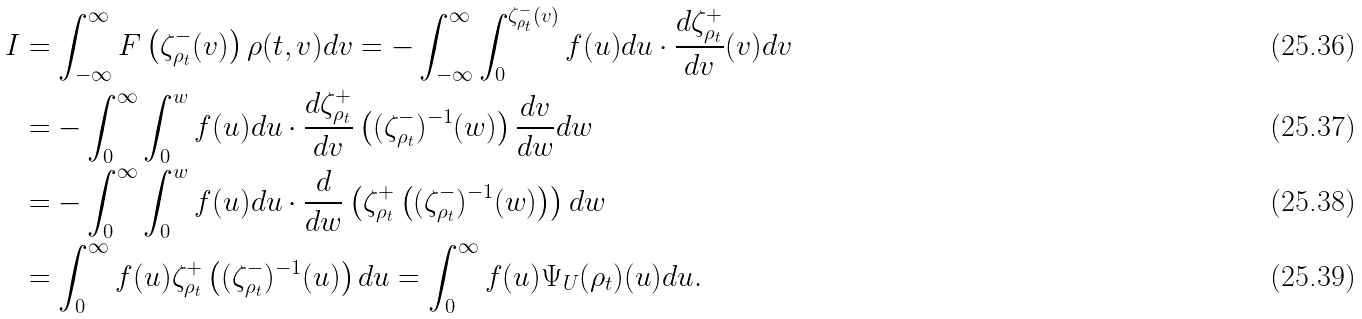Convert formula to latex. <formula><loc_0><loc_0><loc_500><loc_500>I & = \int _ { - \infty } ^ { \infty } F \left ( \zeta ^ { - } _ { \rho _ { t } } ( v ) \right ) \rho ( t , v ) d v = - \int _ { - \infty } ^ { \infty } \int _ { 0 } ^ { \zeta ^ { - } _ { \rho _ { t } } ( v ) } f ( u ) d u \cdot \frac { d \zeta ^ { + } _ { \rho _ { t } } } { d v } ( v ) d v \\ & = - \int _ { 0 } ^ { \infty } \int _ { 0 } ^ { w } f ( u ) d u \cdot \frac { d \zeta ^ { + } _ { \rho _ { t } } } { d v } \left ( ( \zeta ^ { - } _ { \rho _ { t } } ) ^ { - 1 } ( w ) \right ) \frac { d v } { d w } d w \\ & = - \int _ { 0 } ^ { \infty } \int _ { 0 } ^ { w } f ( u ) d u \cdot \frac { d } { d w } \left ( \zeta ^ { + } _ { \rho _ { t } } \left ( ( \zeta ^ { - } _ { \rho _ { t } } ) ^ { - 1 } ( w ) \right ) \right ) d w \\ & = \int _ { 0 } ^ { \infty } f ( u ) \zeta ^ { + } _ { \rho _ { t } } \left ( ( \zeta ^ { - } _ { \rho _ { t } } ) ^ { - 1 } ( u ) \right ) d u = \int _ { 0 } ^ { \infty } f ( u ) \Psi _ { U } ( \rho _ { t } ) ( u ) d u .</formula> 